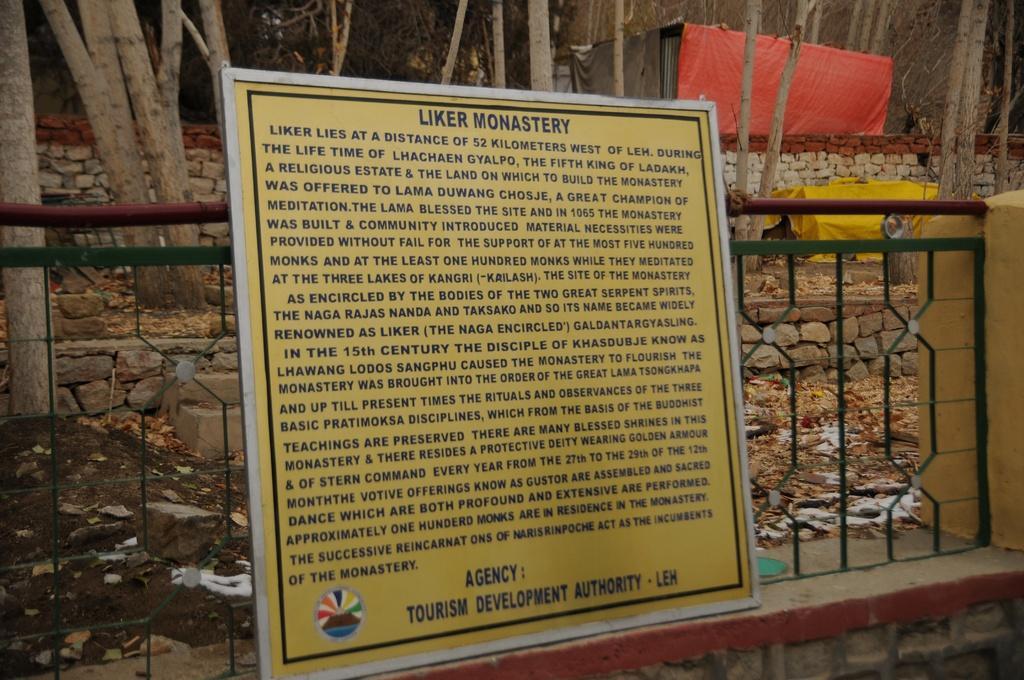How would you summarize this image in a sentence or two? In this image we can see there is a board and grille. In the background there are branches, clothes and walls.   